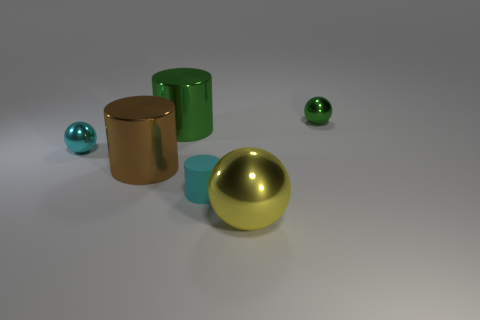There is a object that is in front of the tiny cyan object that is right of the brown shiny thing; what shape is it?
Provide a succinct answer. Sphere. There is a thing that is right of the yellow object; does it have the same shape as the cyan metallic object?
Offer a very short reply. Yes. What color is the shiny cylinder that is behind the cyan metallic object?
Your answer should be compact. Green. How many cylinders are either large red shiny things or brown metal things?
Offer a terse response. 1. What size is the green object left of the shiny sphere that is on the right side of the yellow thing?
Give a very brief answer. Large. Do the tiny matte cylinder and the shiny ball that is to the left of the cyan rubber cylinder have the same color?
Your answer should be very brief. Yes. There is a big shiny ball; what number of metallic things are left of it?
Provide a short and direct response. 3. Are there fewer large metallic things than large brown metal cylinders?
Your response must be concise. No. There is a cylinder that is both to the right of the big brown cylinder and behind the cyan rubber cylinder; how big is it?
Give a very brief answer. Large. Do the metallic ball that is left of the big yellow metal sphere and the matte cylinder have the same color?
Offer a terse response. Yes. 